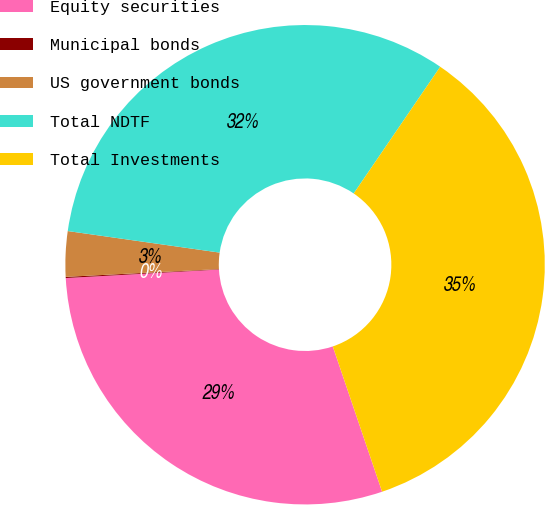Convert chart. <chart><loc_0><loc_0><loc_500><loc_500><pie_chart><fcel>Equity securities<fcel>Municipal bonds<fcel>US government bonds<fcel>Total NDTF<fcel>Total Investments<nl><fcel>29.32%<fcel>0.08%<fcel>3.05%<fcel>32.29%<fcel>35.26%<nl></chart> 